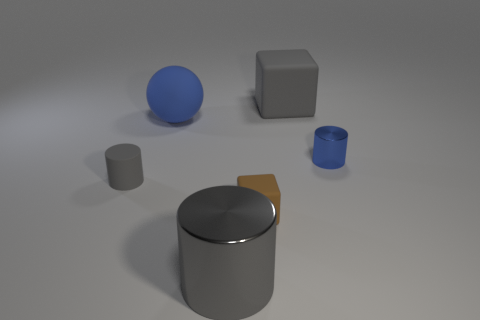Add 1 large matte balls. How many objects exist? 7 Subtract all blocks. How many objects are left? 4 Add 6 small balls. How many small balls exist? 6 Subtract 0 brown balls. How many objects are left? 6 Subtract all tiny red matte cylinders. Subtract all small gray objects. How many objects are left? 5 Add 6 big cubes. How many big cubes are left? 7 